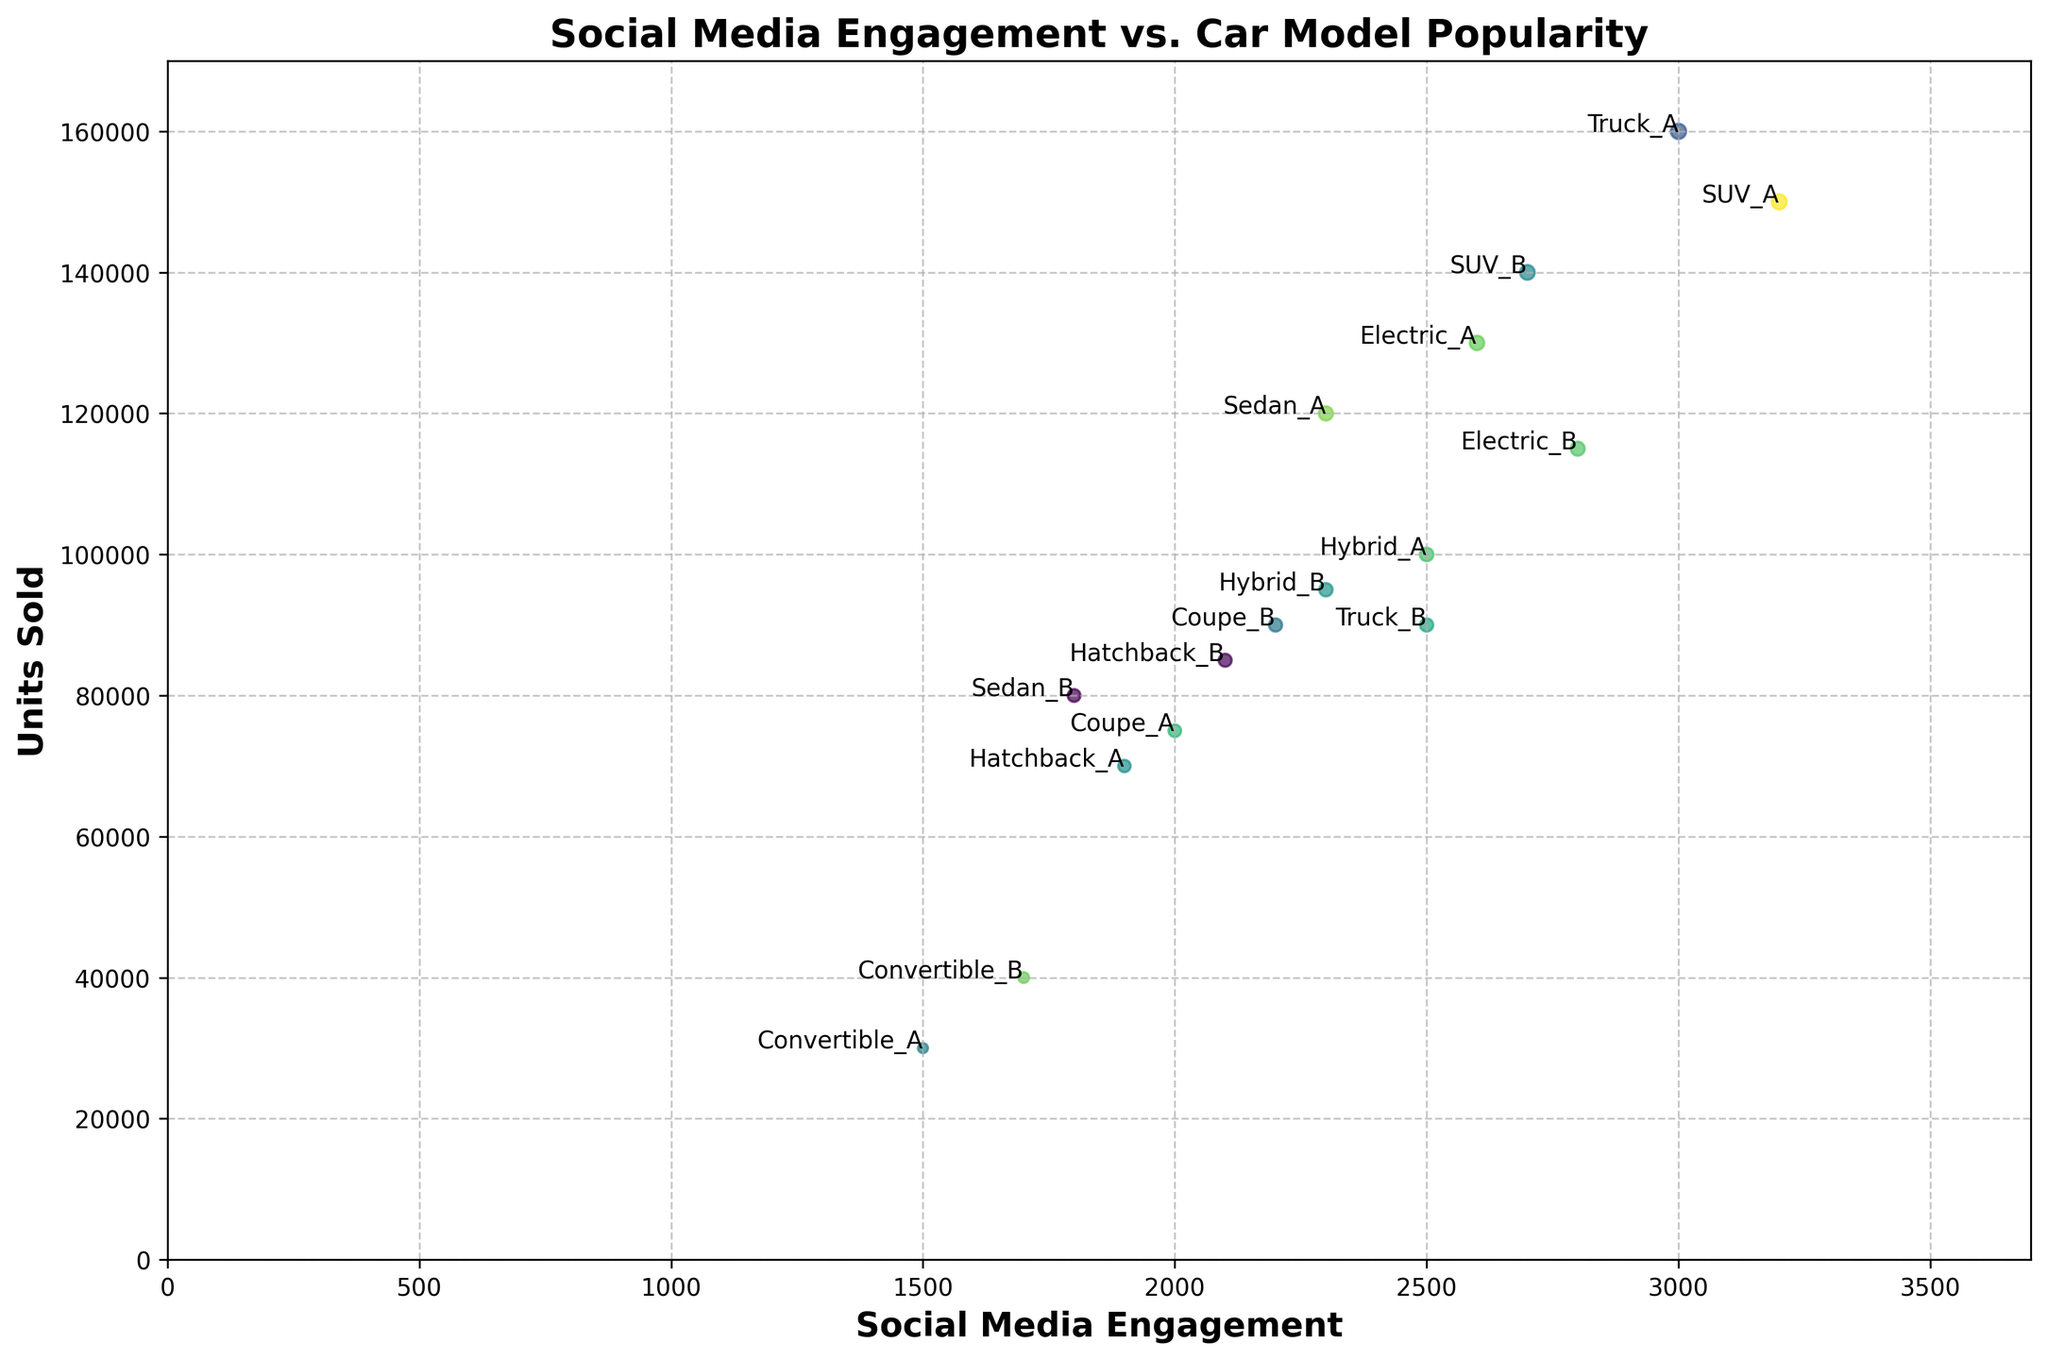Which car model has the highest social media engagement? By looking at the scatter plot, identify the data point that appears furthest to the right on the x-axis, as this represents the highest social media engagement.
Answer: SUV_A What is the difference in units sold between Truck_A and Truck_B? Locate Truck_A and Truck_B on the plot and compare their y-axis values. Truck_A has 160,000 units sold, while Truck_B has 90,000 units sold. Subtract the two values: 160,000 - 90,000.
Answer: 70,000 Which car model has the least units sold, and what is the value? Identify the data point that appears at the lowest position on the y-axis, as this represents the least units sold. This is Convertible_A with 30,000 units sold.
Answer: Convertible_A, 30,000 Are there any models with the same social media engagement but different units sold? If so, list them. Look for data points that are vertically aligned but not the same on the y-axis. Hybrid_B and Sedan_A both have 2,300 social media engagements but different units sold (95,000 and 120,000 respectively).
Answer: Hybrid_B and Sedan_A Which model has a larger social media engagement: Hybrid_A or Electric_A? Locate Hybrid_A and Electric_A on the plot and compare their x-axis (social media engagement) values. Electric_A has 2,600 engagements while Hybrid_A has 2,500 engagements.
Answer: Electric_A Which type of vehicle (sedan, SUV, hatchback, truck, convertible, coupe, electric, hybrid) shows the best overall performance in terms of units sold and social media engagement? Evaluate both social media engagement and units sold for each type. SUVs show strong performance with SUV_A and SUV_B both having high units sold and social media engagement.
Answer: SUV Rank the top three car models in terms of social media engagement. Identify the three data points furthest to the right on the x-axis, which are SUV_A (3,200), Truck_A (3,000), and Electric_B (2,800).
Answer: SUV_A, Truck_A, Electric_B Do models with higher social media engagement tend to have higher units sold? Observe the general trend in the scatter plot. Data points with higher social media engagement (further to the right) generally also have higher units sold (higher on the y-axis).
Answer: Yes What is the average social media engagement for Convertible models? Add the social media engagements of Convertible_A and Convertible_B and divide by 2. (1,500 + 1,700) / 2 = 1,600.
Answer: 1,600 